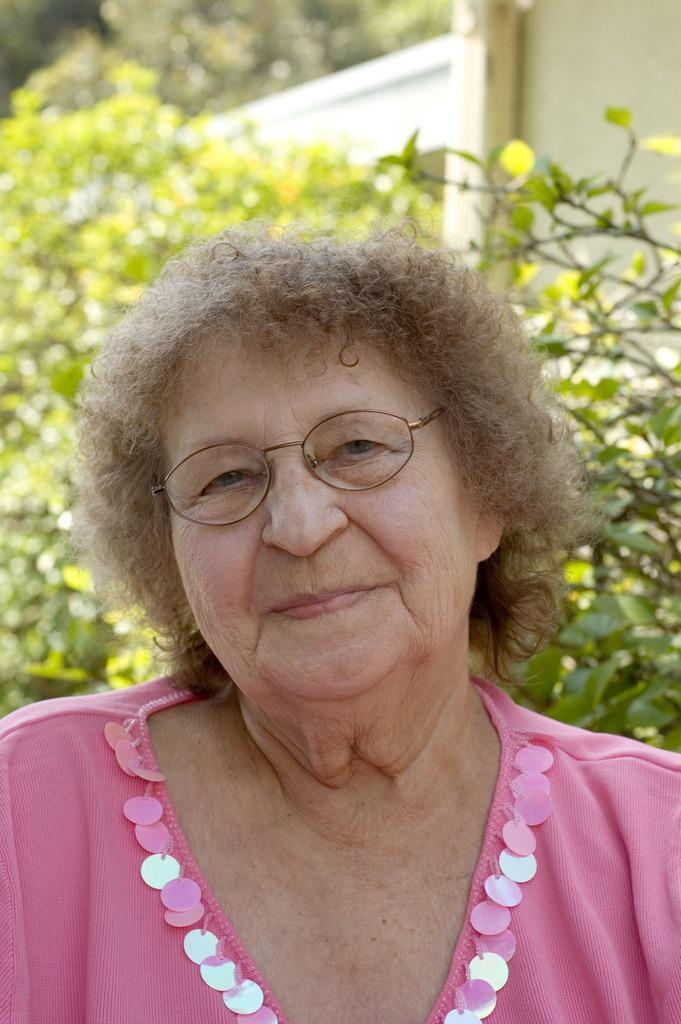Who is present in the image? There is a woman in the image. What accessory is the woman wearing? The woman is wearing spectacles. What can be seen in the background of the image? There are trees and a wall visible in the background of the image. What type of feather can be seen on the woman's hat in the image? There is no feather present on the woman's hat in the image. How does the paste affect the wall in the background of the image? There is no mention of paste in the image, so it cannot be determined how it affects the wall. 